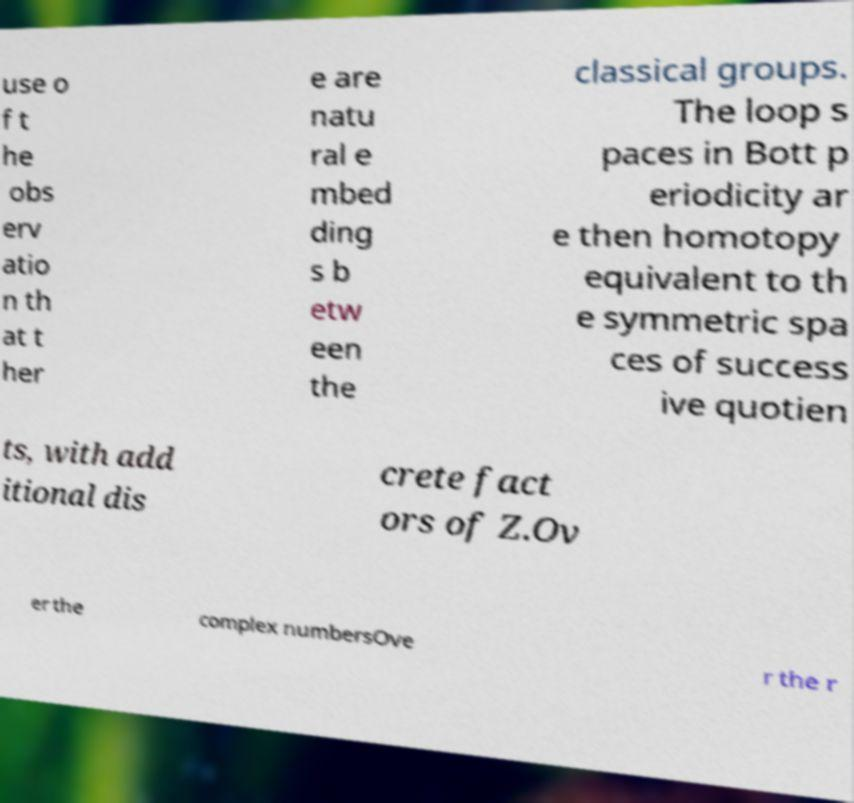Can you accurately transcribe the text from the provided image for me? use o f t he obs erv atio n th at t her e are natu ral e mbed ding s b etw een the classical groups. The loop s paces in Bott p eriodicity ar e then homotopy equivalent to th e symmetric spa ces of success ive quotien ts, with add itional dis crete fact ors of Z.Ov er the complex numbersOve r the r 